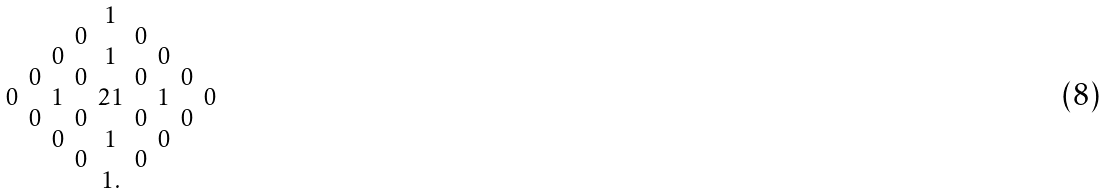<formula> <loc_0><loc_0><loc_500><loc_500>\begin{smallmatrix} & & & & 1 \\ & & & 0 & & 0 \\ & & 0 & & 1 & & 0 \\ & 0 & & 0 & & 0 & & 0 \\ 0 & & 1 & & 2 1 & & 1 & & 0 \\ & 0 & & 0 & & 0 & & 0 \\ & & 0 & & 1 & & 0 \\ & & & 0 & & 0 \\ & & & & 1 . \end{smallmatrix}</formula> 